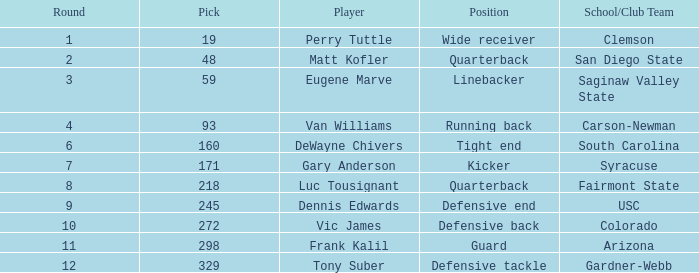Who plays linebacker? Eugene Marve. 